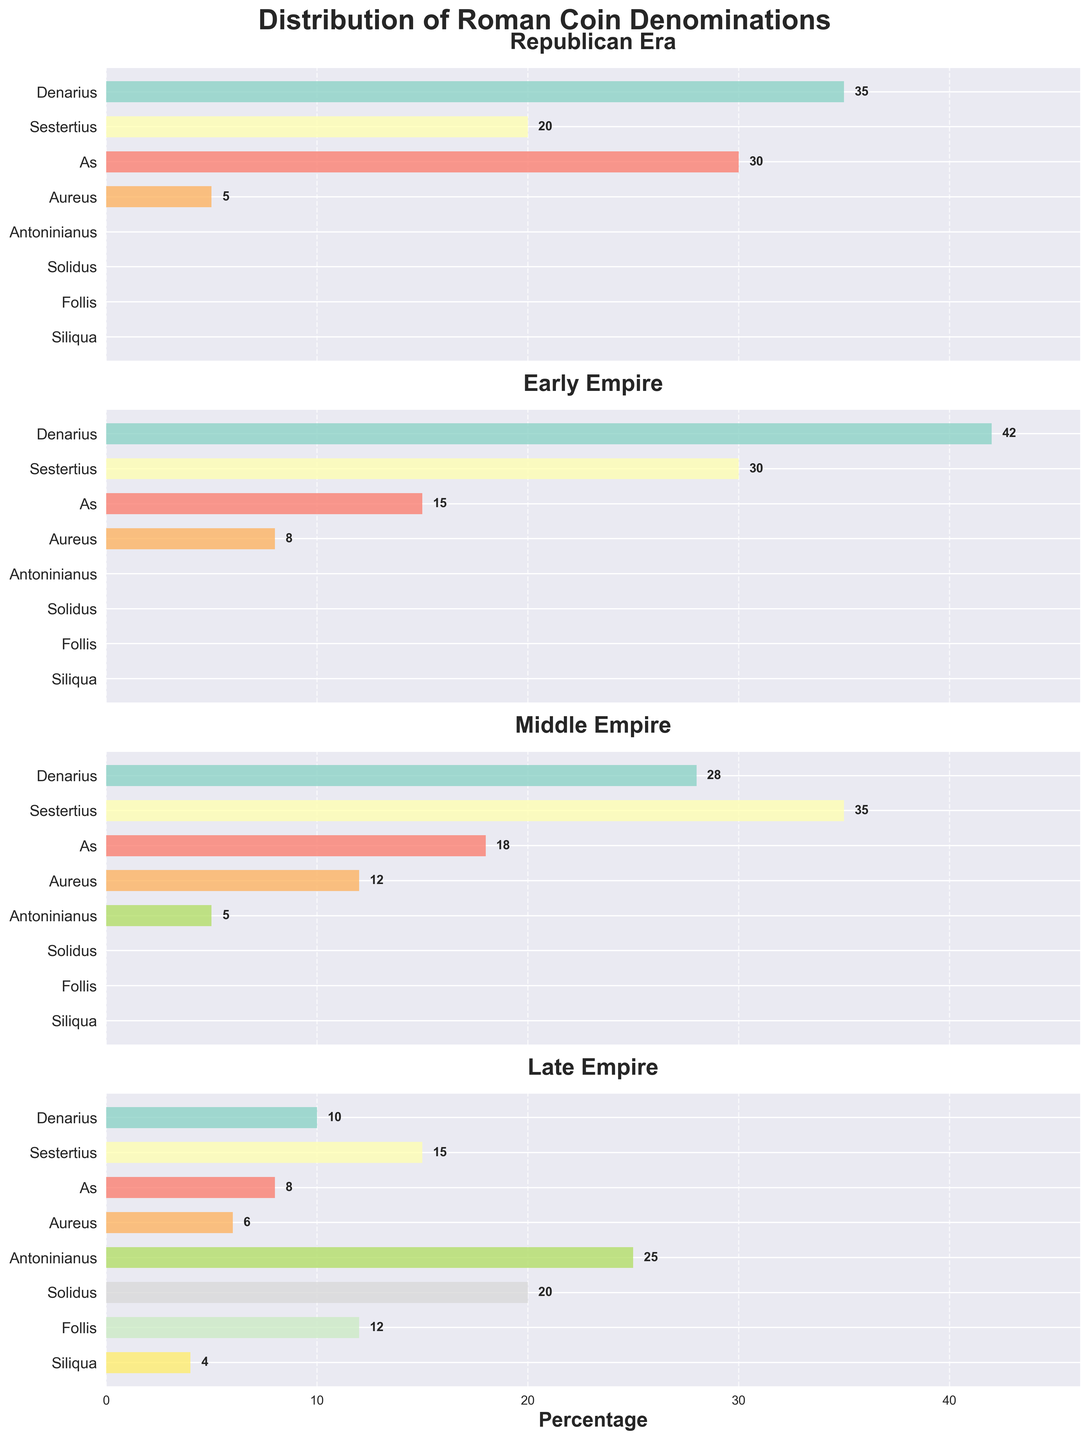What is the title of the figure? The title is usually placed at the top of the figure for easy identification. By looking at the top part, the title is clear and bold.
Answer: Distribution of Roman Coin Denominations Which denomination has the highest count in the Republican Era? By looking at the Republican Era subplot, observe the lengths of the bars. The Denarius has the longest bar.
Answer: Denarius In the Middle Empire, how does the count of Sestertius compare to the count of As? Look at the Middle Empire subplot and compare the lengths of the bars for Sestertius and As. The Sestertius bar is longer than the As bar.
Answer: Sestertius is greater than As Which denominations only appear from the Late Empire era? Examine the bars in the Republican, Early Empire, and Middle Empire subplots, then identify which bars are non-existent in those eras but appear in the Late Empire subplot.
Answer: Solidus, Follis, Siliqua What is the combined count of Aureus coins in the Early and Middle Empires? Look at the values of Aureus in both the Early and Middle Empire subplots and sum them up. Early Empire (8) + Middle Empire (12) = 20.
Answer: 20 Which era has the highest variety of coin denominations? Count the number of different denominations with non-zero counts in each subplot. The Late Empire subplot has the highest count.
Answer: Late Empire For the Early Empire, how many more Denarius are there compared to Aureus? Look at the values for Denarius and Aureus in the Early Empire subplot. Calculate the difference (Denarius: 42, Aureus: 8). 42 - 8 = 34.
Answer: 34 more What is the average count of Denarius coins across all eras? Sum the counts of Denarius across all subplots and divide by the number of eras. (35 + 42 + 28 + 10) / 4 = 28.75.
Answer: 28.75 In which era does the Antoninianus denomination first appear? Notice which subplot the Antoninianus bar first appears in. The Middle Empire subplot shows its initial appearance.
Answer: Middle Empire Which denomination has the least counts in the Republican Era? Identify the shortest bar in the Republican Era subplot. The shortest bar belongs to the Aureus.
Answer: Aureus 